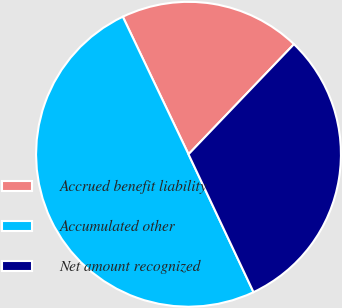Convert chart. <chart><loc_0><loc_0><loc_500><loc_500><pie_chart><fcel>Accrued benefit liability<fcel>Accumulated other<fcel>Net amount recognized<nl><fcel>19.25%<fcel>49.92%<fcel>30.83%<nl></chart> 